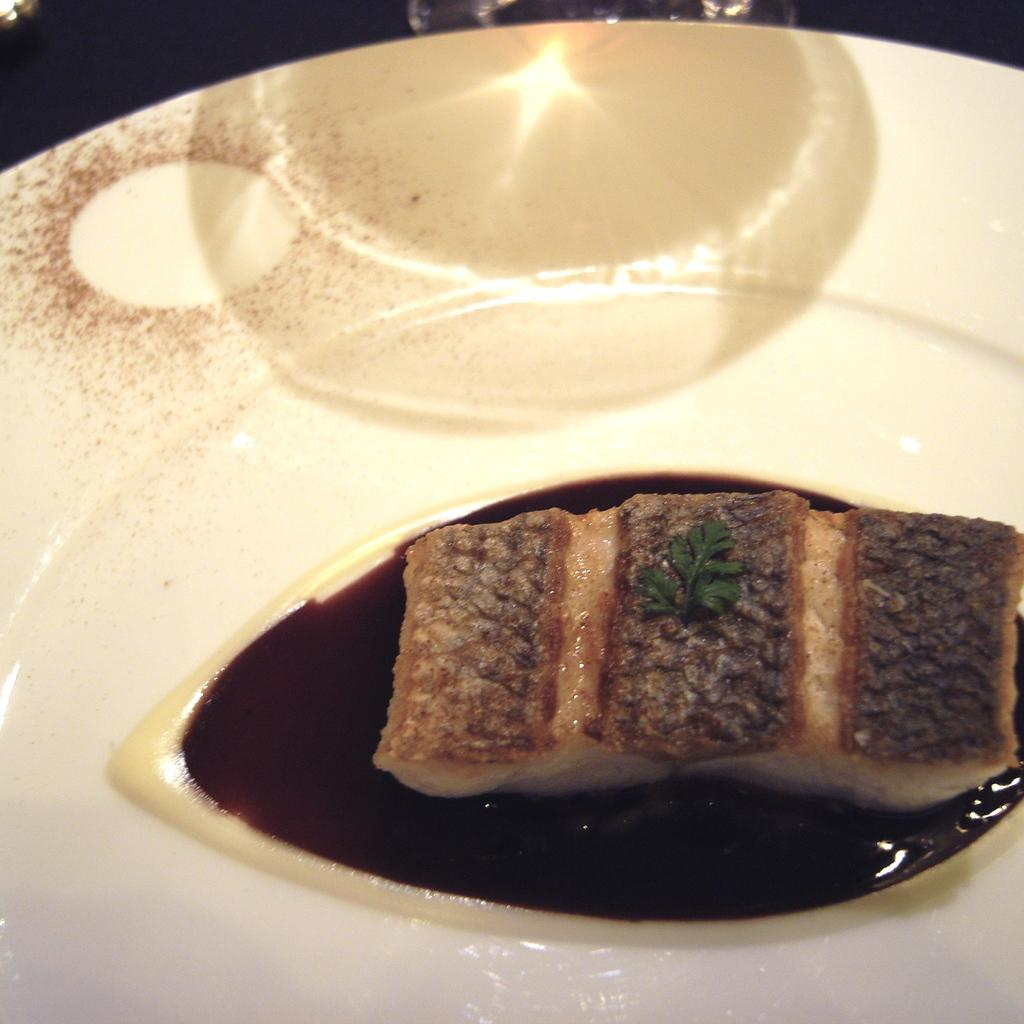What is present on the plate in the image? The plate contains a food item. What is the color of the plate? The plate is white in color. Can you describe any additional features on the plate? There is a shadow of an object on the plate. How many quarters are on the plate in the image? There are no quarters present on the plate in the image. What type of cherries are on the plate in the image? There are no cherries present on the plate in the image. 